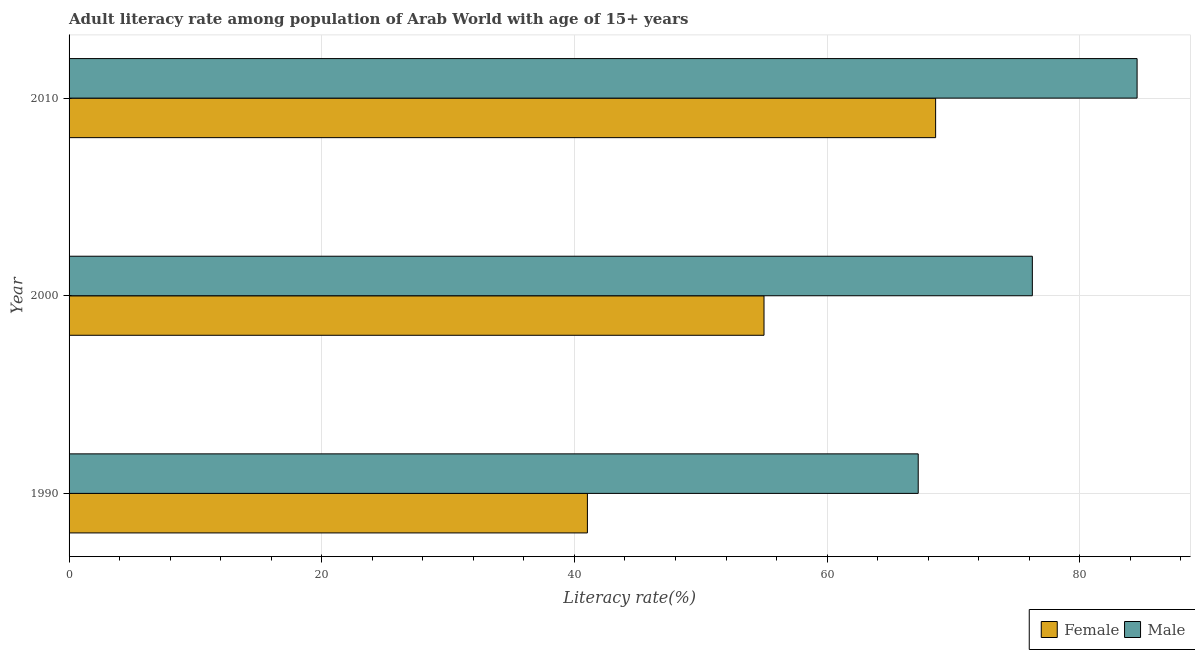How many groups of bars are there?
Your answer should be compact. 3. What is the label of the 3rd group of bars from the top?
Your answer should be very brief. 1990. What is the female adult literacy rate in 2000?
Your answer should be very brief. 55. Across all years, what is the maximum female adult literacy rate?
Ensure brevity in your answer.  68.59. Across all years, what is the minimum male adult literacy rate?
Your answer should be very brief. 67.21. In which year was the female adult literacy rate maximum?
Your answer should be very brief. 2010. In which year was the female adult literacy rate minimum?
Ensure brevity in your answer.  1990. What is the total female adult literacy rate in the graph?
Give a very brief answer. 164.61. What is the difference between the female adult literacy rate in 1990 and that in 2000?
Give a very brief answer. -13.98. What is the difference between the male adult literacy rate in 2010 and the female adult literacy rate in 1990?
Ensure brevity in your answer.  43.51. What is the average female adult literacy rate per year?
Keep it short and to the point. 54.87. In the year 1990, what is the difference between the male adult literacy rate and female adult literacy rate?
Give a very brief answer. 26.18. In how many years, is the male adult literacy rate greater than 56 %?
Offer a terse response. 3. What is the ratio of the female adult literacy rate in 1990 to that in 2010?
Offer a very short reply. 0.6. What is the difference between the highest and the second highest female adult literacy rate?
Your answer should be compact. 13.58. What is the difference between the highest and the lowest male adult literacy rate?
Your answer should be very brief. 17.32. In how many years, is the male adult literacy rate greater than the average male adult literacy rate taken over all years?
Offer a terse response. 2. What does the 2nd bar from the top in 2010 represents?
Offer a very short reply. Female. What does the 2nd bar from the bottom in 1990 represents?
Your response must be concise. Male. How many bars are there?
Your answer should be very brief. 6. Are all the bars in the graph horizontal?
Keep it short and to the point. Yes. Are the values on the major ticks of X-axis written in scientific E-notation?
Your response must be concise. No. Does the graph contain any zero values?
Keep it short and to the point. No. Does the graph contain grids?
Provide a short and direct response. Yes. Where does the legend appear in the graph?
Your response must be concise. Bottom right. How many legend labels are there?
Your response must be concise. 2. How are the legend labels stacked?
Your response must be concise. Horizontal. What is the title of the graph?
Your response must be concise. Adult literacy rate among population of Arab World with age of 15+ years. Does "Residents" appear as one of the legend labels in the graph?
Make the answer very short. No. What is the label or title of the X-axis?
Your response must be concise. Literacy rate(%). What is the label or title of the Y-axis?
Provide a succinct answer. Year. What is the Literacy rate(%) of Female in 1990?
Give a very brief answer. 41.02. What is the Literacy rate(%) in Male in 1990?
Make the answer very short. 67.21. What is the Literacy rate(%) of Female in 2000?
Keep it short and to the point. 55. What is the Literacy rate(%) in Male in 2000?
Offer a terse response. 76.24. What is the Literacy rate(%) in Female in 2010?
Give a very brief answer. 68.59. What is the Literacy rate(%) of Male in 2010?
Give a very brief answer. 84.53. Across all years, what is the maximum Literacy rate(%) in Female?
Keep it short and to the point. 68.59. Across all years, what is the maximum Literacy rate(%) of Male?
Your answer should be very brief. 84.53. Across all years, what is the minimum Literacy rate(%) of Female?
Provide a short and direct response. 41.02. Across all years, what is the minimum Literacy rate(%) of Male?
Your answer should be very brief. 67.21. What is the total Literacy rate(%) in Female in the graph?
Your answer should be compact. 164.61. What is the total Literacy rate(%) of Male in the graph?
Offer a terse response. 227.98. What is the difference between the Literacy rate(%) of Female in 1990 and that in 2000?
Provide a short and direct response. -13.98. What is the difference between the Literacy rate(%) in Male in 1990 and that in 2000?
Provide a short and direct response. -9.03. What is the difference between the Literacy rate(%) of Female in 1990 and that in 2010?
Your response must be concise. -27.56. What is the difference between the Literacy rate(%) of Male in 1990 and that in 2010?
Give a very brief answer. -17.32. What is the difference between the Literacy rate(%) of Female in 2000 and that in 2010?
Offer a very short reply. -13.58. What is the difference between the Literacy rate(%) of Male in 2000 and that in 2010?
Provide a succinct answer. -8.29. What is the difference between the Literacy rate(%) of Female in 1990 and the Literacy rate(%) of Male in 2000?
Your response must be concise. -35.22. What is the difference between the Literacy rate(%) in Female in 1990 and the Literacy rate(%) in Male in 2010?
Ensure brevity in your answer.  -43.51. What is the difference between the Literacy rate(%) of Female in 2000 and the Literacy rate(%) of Male in 2010?
Keep it short and to the point. -29.53. What is the average Literacy rate(%) of Female per year?
Your response must be concise. 54.87. What is the average Literacy rate(%) in Male per year?
Your answer should be very brief. 75.99. In the year 1990, what is the difference between the Literacy rate(%) in Female and Literacy rate(%) in Male?
Your answer should be compact. -26.18. In the year 2000, what is the difference between the Literacy rate(%) in Female and Literacy rate(%) in Male?
Provide a succinct answer. -21.24. In the year 2010, what is the difference between the Literacy rate(%) in Female and Literacy rate(%) in Male?
Ensure brevity in your answer.  -15.95. What is the ratio of the Literacy rate(%) in Female in 1990 to that in 2000?
Your response must be concise. 0.75. What is the ratio of the Literacy rate(%) in Male in 1990 to that in 2000?
Provide a succinct answer. 0.88. What is the ratio of the Literacy rate(%) in Female in 1990 to that in 2010?
Keep it short and to the point. 0.6. What is the ratio of the Literacy rate(%) of Male in 1990 to that in 2010?
Ensure brevity in your answer.  0.8. What is the ratio of the Literacy rate(%) in Female in 2000 to that in 2010?
Offer a terse response. 0.8. What is the ratio of the Literacy rate(%) of Male in 2000 to that in 2010?
Offer a terse response. 0.9. What is the difference between the highest and the second highest Literacy rate(%) of Female?
Offer a terse response. 13.58. What is the difference between the highest and the second highest Literacy rate(%) of Male?
Offer a very short reply. 8.29. What is the difference between the highest and the lowest Literacy rate(%) in Female?
Keep it short and to the point. 27.56. What is the difference between the highest and the lowest Literacy rate(%) in Male?
Provide a succinct answer. 17.32. 